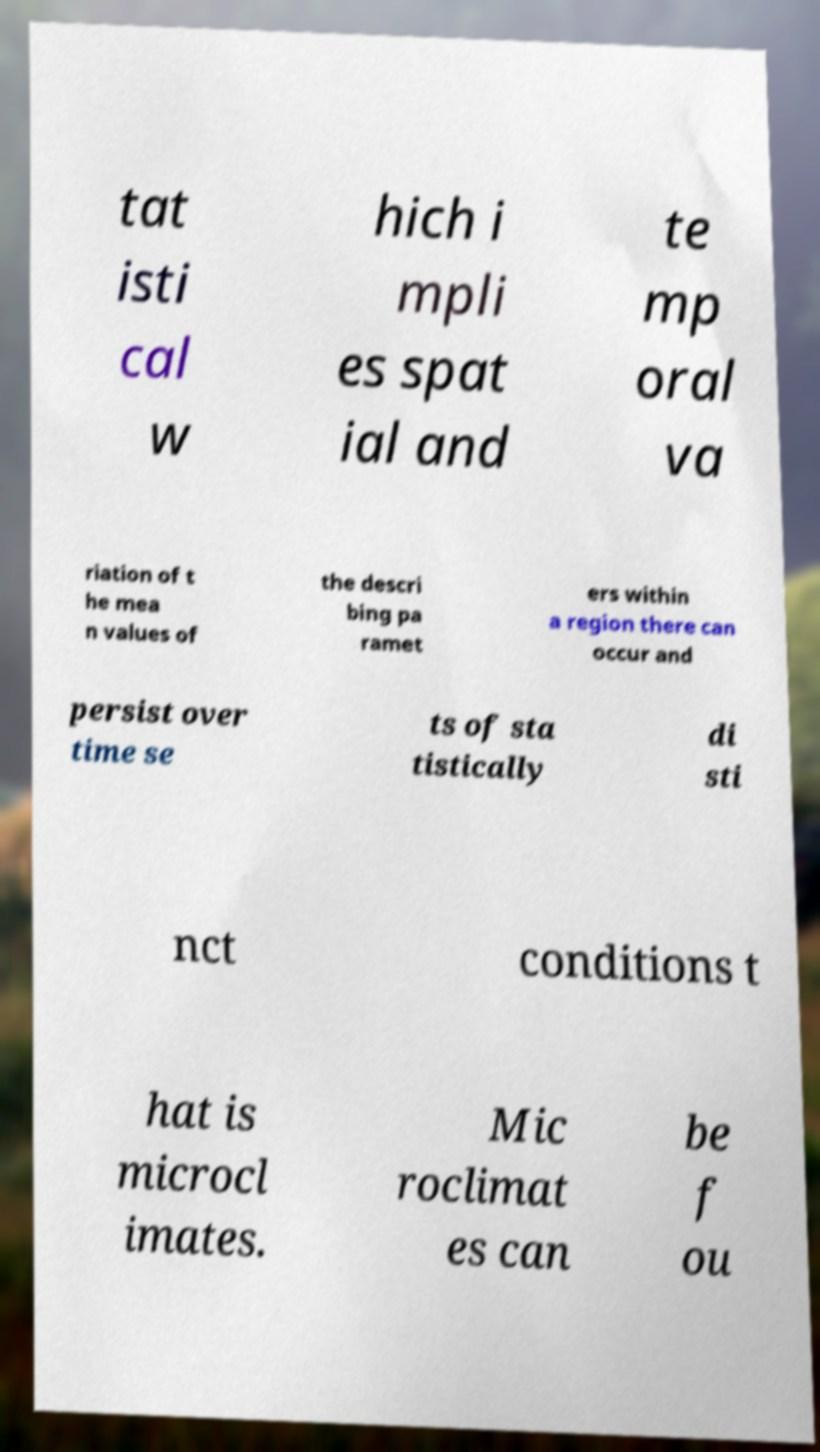What messages or text are displayed in this image? I need them in a readable, typed format. tat isti cal w hich i mpli es spat ial and te mp oral va riation of t he mea n values of the descri bing pa ramet ers within a region there can occur and persist over time se ts of sta tistically di sti nct conditions t hat is microcl imates. Mic roclimat es can be f ou 